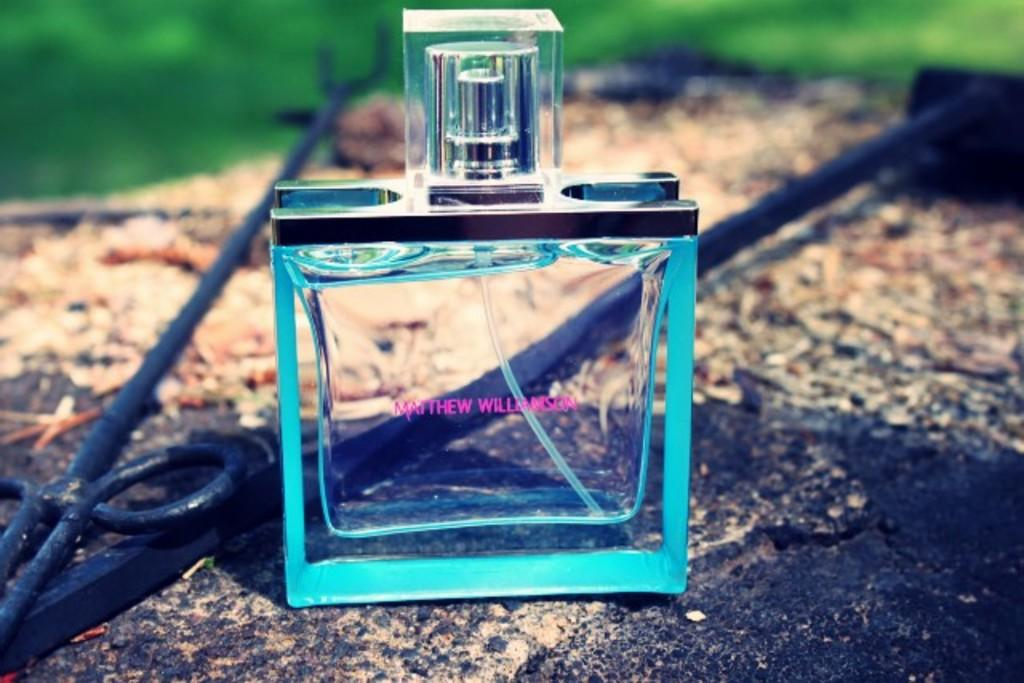<image>
Create a compact narrative representing the image presented. Bottle of Matthew Williamson ourdoors on a wooden table. 